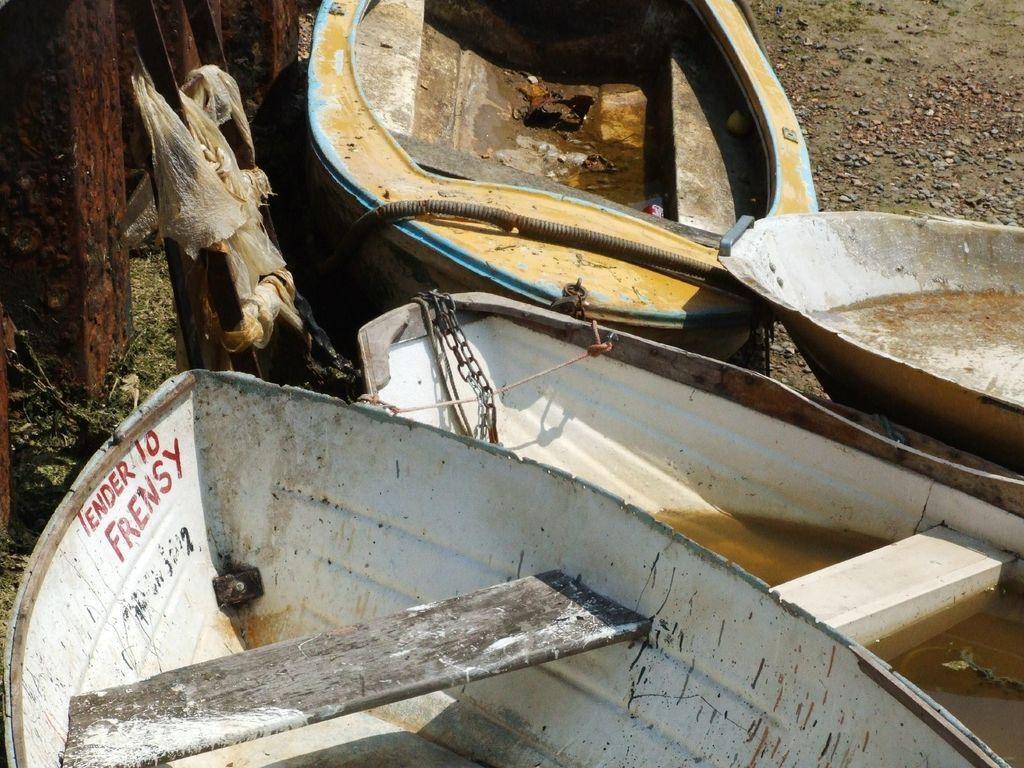How would you summarize this image in a sentence or two? In this image we can see boats on the ground. 